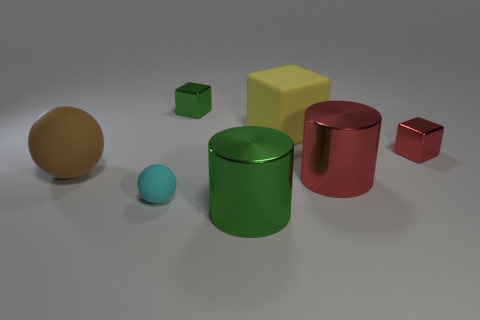Add 1 brown shiny balls. How many objects exist? 8 Subtract all cylinders. How many objects are left? 5 Add 6 tiny things. How many tiny things exist? 9 Subtract 1 yellow cubes. How many objects are left? 6 Subtract all tiny cyan rubber balls. Subtract all large red shiny cylinders. How many objects are left? 5 Add 4 large green objects. How many large green objects are left? 5 